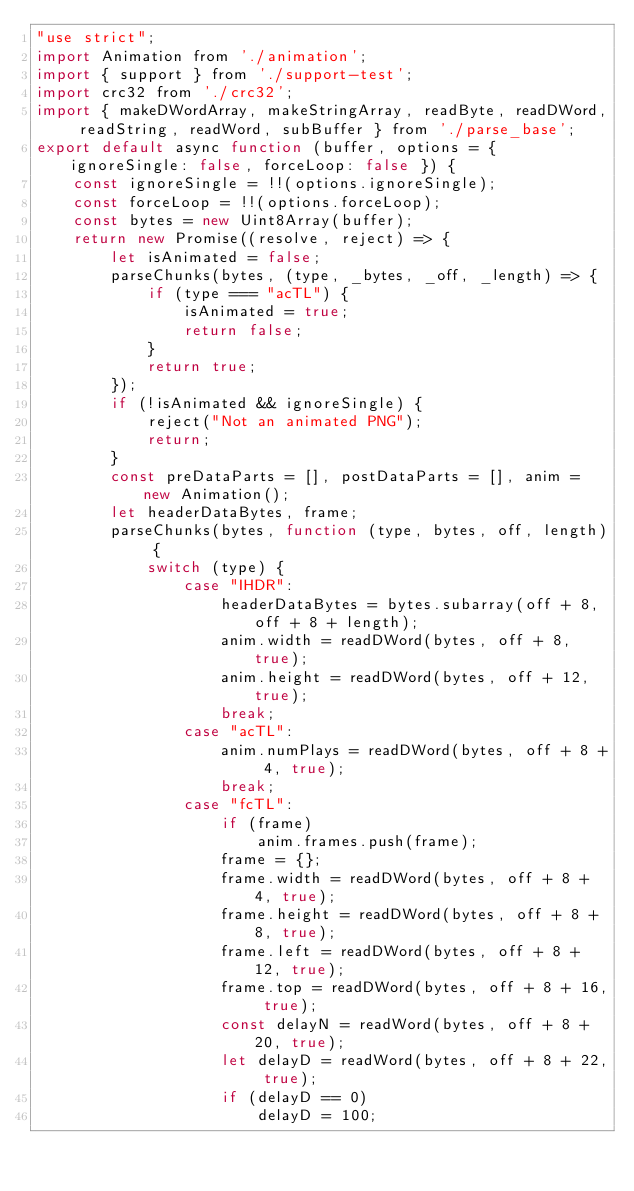<code> <loc_0><loc_0><loc_500><loc_500><_JavaScript_>"use strict";
import Animation from './animation';
import { support } from './support-test';
import crc32 from './crc32';
import { makeDWordArray, makeStringArray, readByte, readDWord, readString, readWord, subBuffer } from './parse_base';
export default async function (buffer, options = { ignoreSingle: false, forceLoop: false }) {
    const ignoreSingle = !!(options.ignoreSingle);
    const forceLoop = !!(options.forceLoop);
    const bytes = new Uint8Array(buffer);
    return new Promise((resolve, reject) => {
        let isAnimated = false;
        parseChunks(bytes, (type, _bytes, _off, _length) => {
            if (type === "acTL") {
                isAnimated = true;
                return false;
            }
            return true;
        });
        if (!isAnimated && ignoreSingle) {
            reject("Not an animated PNG");
            return;
        }
        const preDataParts = [], postDataParts = [], anim = new Animation();
        let headerDataBytes, frame;
        parseChunks(bytes, function (type, bytes, off, length) {
            switch (type) {
                case "IHDR":
                    headerDataBytes = bytes.subarray(off + 8, off + 8 + length);
                    anim.width = readDWord(bytes, off + 8, true);
                    anim.height = readDWord(bytes, off + 12, true);
                    break;
                case "acTL":
                    anim.numPlays = readDWord(bytes, off + 8 + 4, true);
                    break;
                case "fcTL":
                    if (frame)
                        anim.frames.push(frame);
                    frame = {};
                    frame.width = readDWord(bytes, off + 8 + 4, true);
                    frame.height = readDWord(bytes, off + 8 + 8, true);
                    frame.left = readDWord(bytes, off + 8 + 12, true);
                    frame.top = readDWord(bytes, off + 8 + 16, true);
                    const delayN = readWord(bytes, off + 8 + 20, true);
                    let delayD = readWord(bytes, off + 8 + 22, true);
                    if (delayD == 0)
                        delayD = 100;</code> 